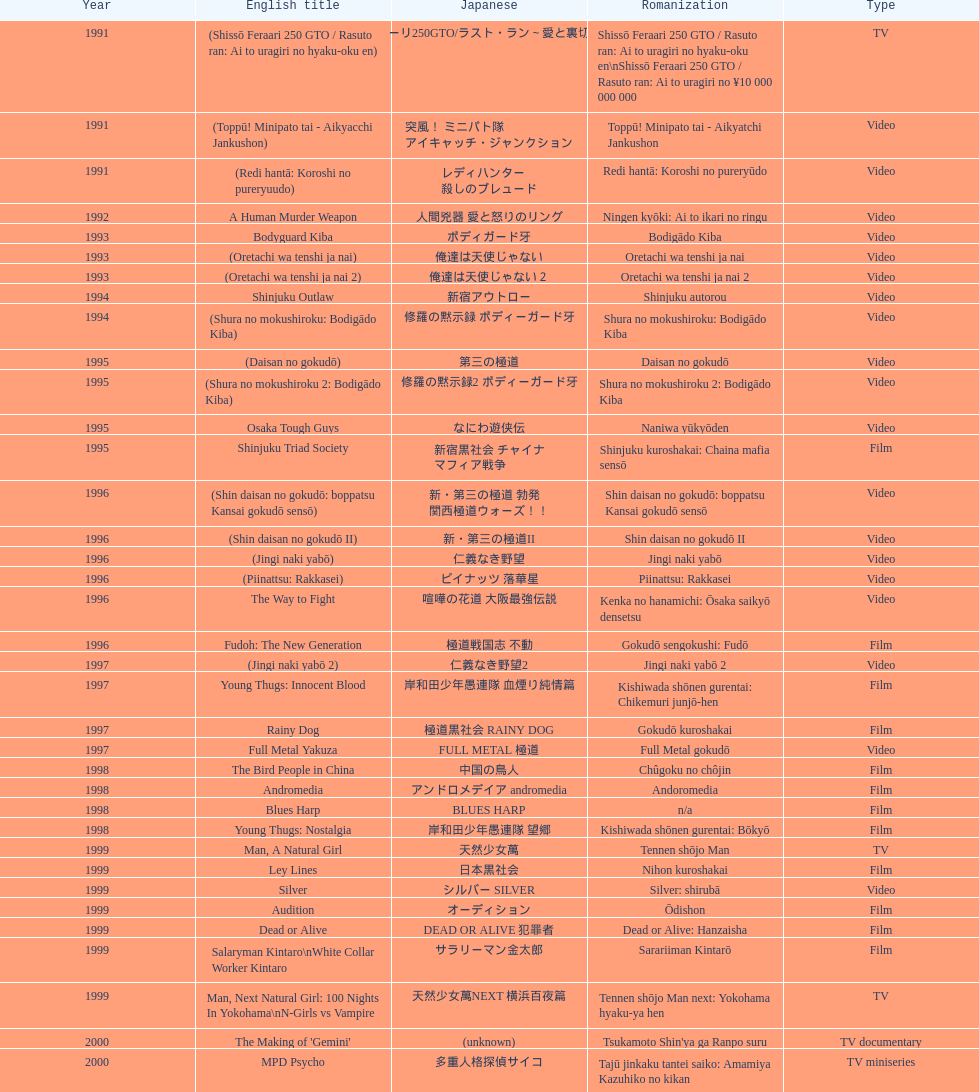Which title is listed next after "the way to fight"? Fudoh: The New Generation. 